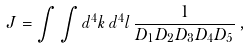Convert formula to latex. <formula><loc_0><loc_0><loc_500><loc_500>J = \int \int d ^ { 4 } k \, d ^ { 4 } l \, \frac { 1 } { D _ { 1 } D _ { 2 } D _ { 3 } D _ { 4 } D _ { 5 } } \, ,</formula> 